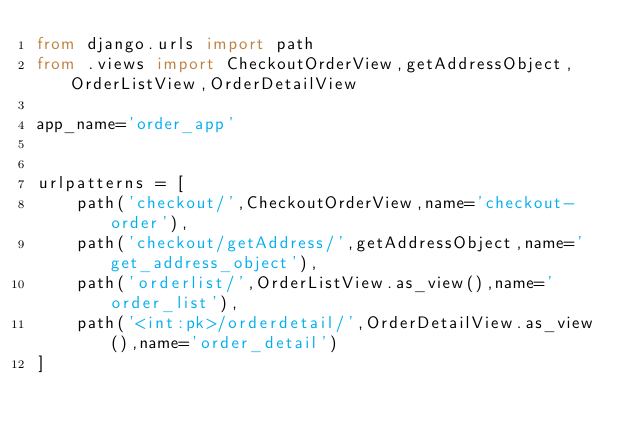<code> <loc_0><loc_0><loc_500><loc_500><_Python_>from django.urls import path
from .views import CheckoutOrderView,getAddressObject,OrderListView,OrderDetailView

app_name='order_app'


urlpatterns = [
    path('checkout/',CheckoutOrderView,name='checkout-order'),
    path('checkout/getAddress/',getAddressObject,name='get_address_object'),
    path('orderlist/',OrderListView.as_view(),name='order_list'),
    path('<int:pk>/orderdetail/',OrderDetailView.as_view(),name='order_detail')
]
</code> 